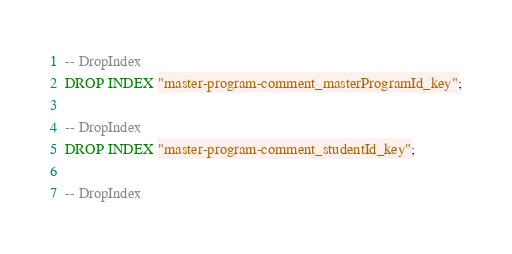Convert code to text. <code><loc_0><loc_0><loc_500><loc_500><_SQL_>-- DropIndex
DROP INDEX "master-program-comment_masterProgramId_key";

-- DropIndex
DROP INDEX "master-program-comment_studentId_key";

-- DropIndex</code> 